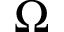<formula> <loc_0><loc_0><loc_500><loc_500>\Omega</formula> 